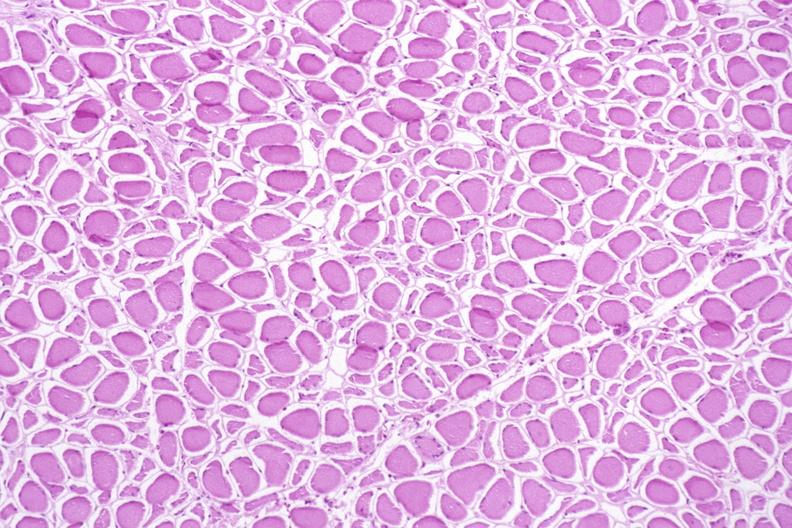does intraductal papillomatosis show skeletal muscle, atrophy due to immobilization cast?
Answer the question using a single word or phrase. No 